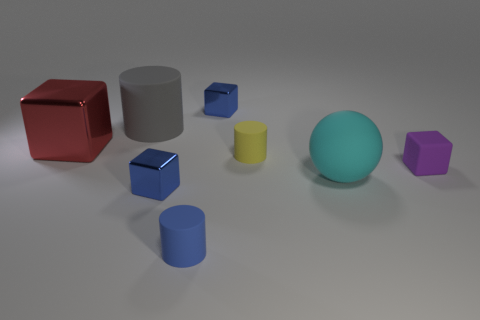Subtract all small rubber blocks. How many blocks are left? 3 Subtract all spheres. How many objects are left? 7 Subtract 3 blocks. How many blocks are left? 1 Add 2 small yellow matte cylinders. How many objects exist? 10 Subtract 0 gray blocks. How many objects are left? 8 Subtract all cyan blocks. Subtract all red balls. How many blocks are left? 4 Subtract all purple blocks. How many blue cylinders are left? 1 Subtract all tiny purple things. Subtract all big gray cylinders. How many objects are left? 6 Add 6 red metallic cubes. How many red metallic cubes are left? 7 Add 3 metal cylinders. How many metal cylinders exist? 3 